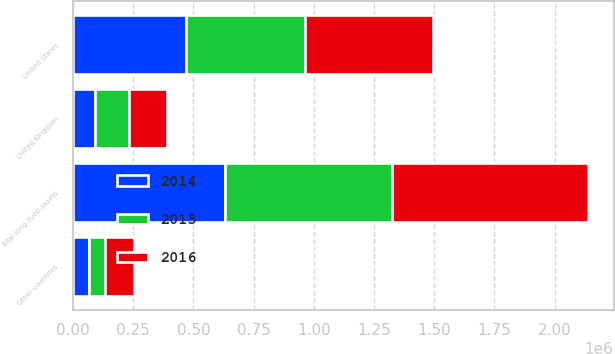Convert chart to OTSL. <chart><loc_0><loc_0><loc_500><loc_500><stacked_bar_chart><ecel><fcel>United States<fcel>United Kingdom<fcel>Other countries<fcel>Total long-lived assets<nl><fcel>2016<fcel>531425<fcel>159689<fcel>120462<fcel>811576<nl><fcel>2015<fcel>493300<fcel>138546<fcel>64721<fcel>696567<nl><fcel>2014<fcel>469450<fcel>92813<fcel>67724<fcel>629987<nl></chart> 